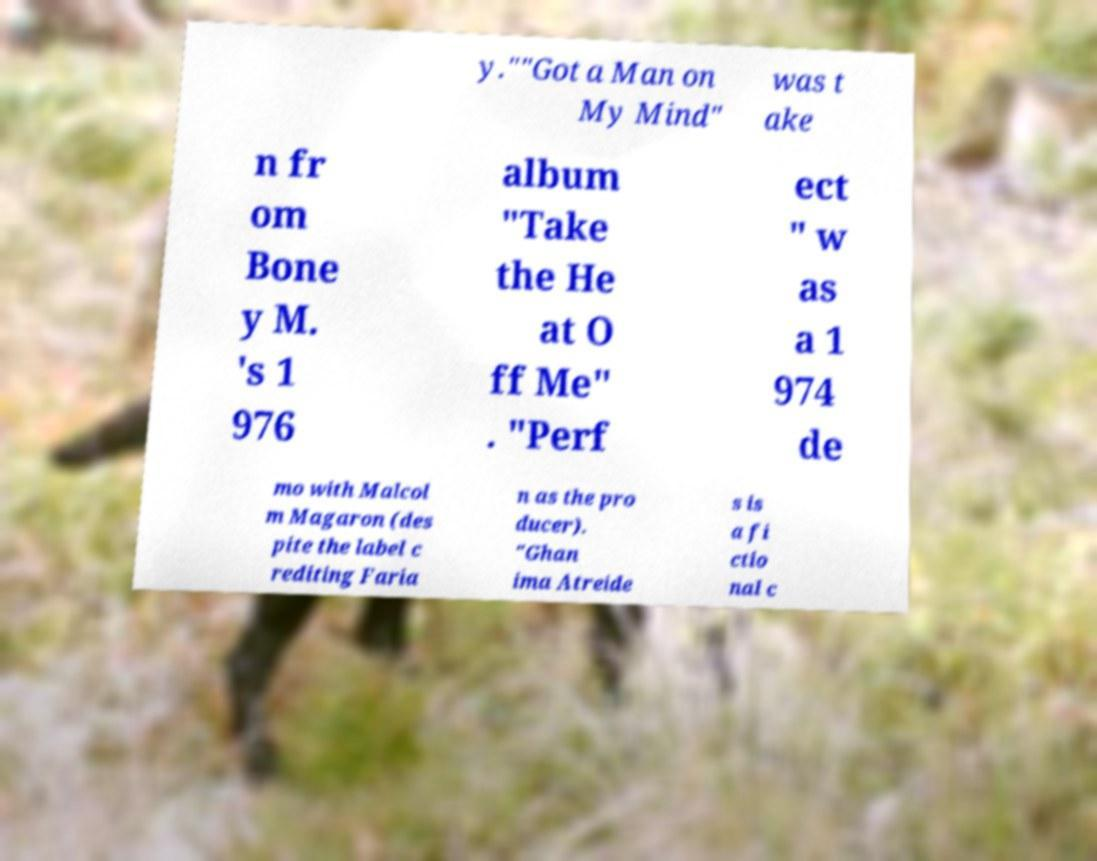There's text embedded in this image that I need extracted. Can you transcribe it verbatim? y.""Got a Man on My Mind" was t ake n fr om Bone y M. 's 1 976 album "Take the He at O ff Me" . "Perf ect " w as a 1 974 de mo with Malcol m Magaron (des pite the label c rediting Faria n as the pro ducer). "Ghan ima Atreide s is a fi ctio nal c 